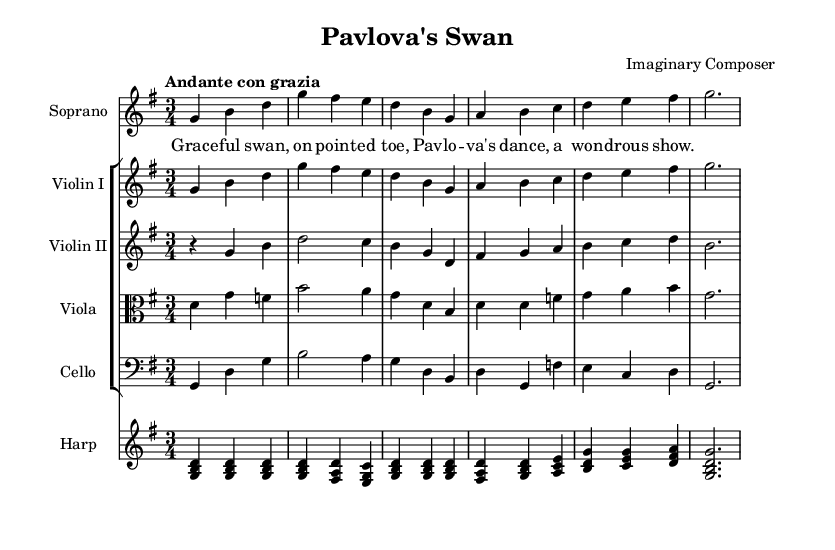What is the key signature of this music? The key signature indicated in the music is one sharp, which corresponds to the key of G major. This is identified by looking at the key signature at the beginning of the staff, which shows one sharp (F#).
Answer: G major What is the time signature of this music? The time signature shown at the beginning of the score is three over four, indicated by the 3/4 symbol. This means each measure contains three beats, and each beat is a quarter note.
Answer: 3/4 What is the tempo marking for this piece? The tempo marking is "Andante con grazia," which is a common descriptor in music that suggests a moderately slow and graceful pace. This can be found at the beginning of the score, under the title.
Answer: Andante con grazia Which instrument plays the melody? The melody is written for the soprano voice, as indicated on the staff dedicated to "Soprano" in the score. This staff contains the primary vocal line, which aligns with typical opera structure.
Answer: Soprano What type of harmony is featured in the harp part? The harp part features arpeggiated chords where the notes of each chord are played in succession, reflecting a typical harmonic texture that supports the melody. This can be observed in the harp’s written music, which consists of broken chords throughout.
Answer: Arpeggiated How many different string instruments are part of the ensemble? The score includes four string instruments: Violin I, Violin II, Viola, and Cello, which are each on separate staves. This information can be derived from the staff groupings and instrument names indicated at the beginning of each staff.
Answer: Four What is the theme of the opera represented in the lyrics? The lyrics in the verse convey a portrayal of a graceful swan, specifically referencing "Pavlova's dance," which highlights the beauty and artistry associated with the famous ballet dancer Anna Pavlova. This thematic representation is explicitly stated in the text provided.
Answer: Pavlova's dance 